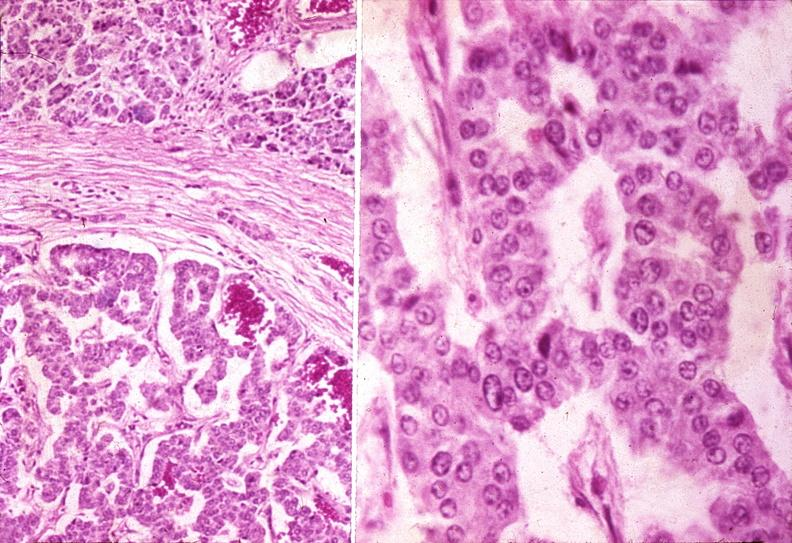s pancreas present?
Answer the question using a single word or phrase. Yes 